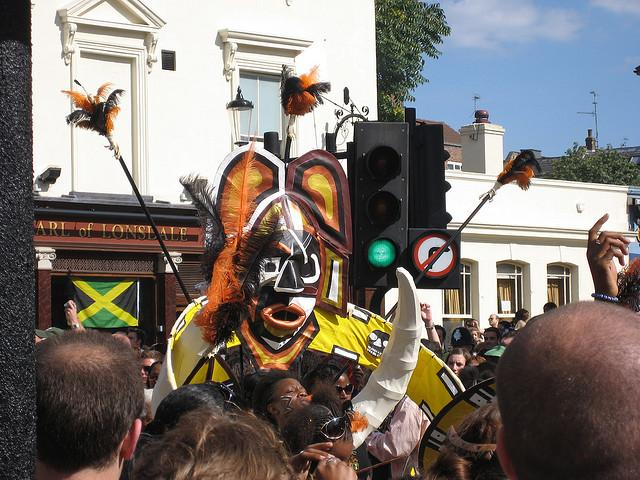What does the color of traffic light in the above picture imply to road users? Please explain your reasoning. go. The traffic light is green so it is safe to proceed. 